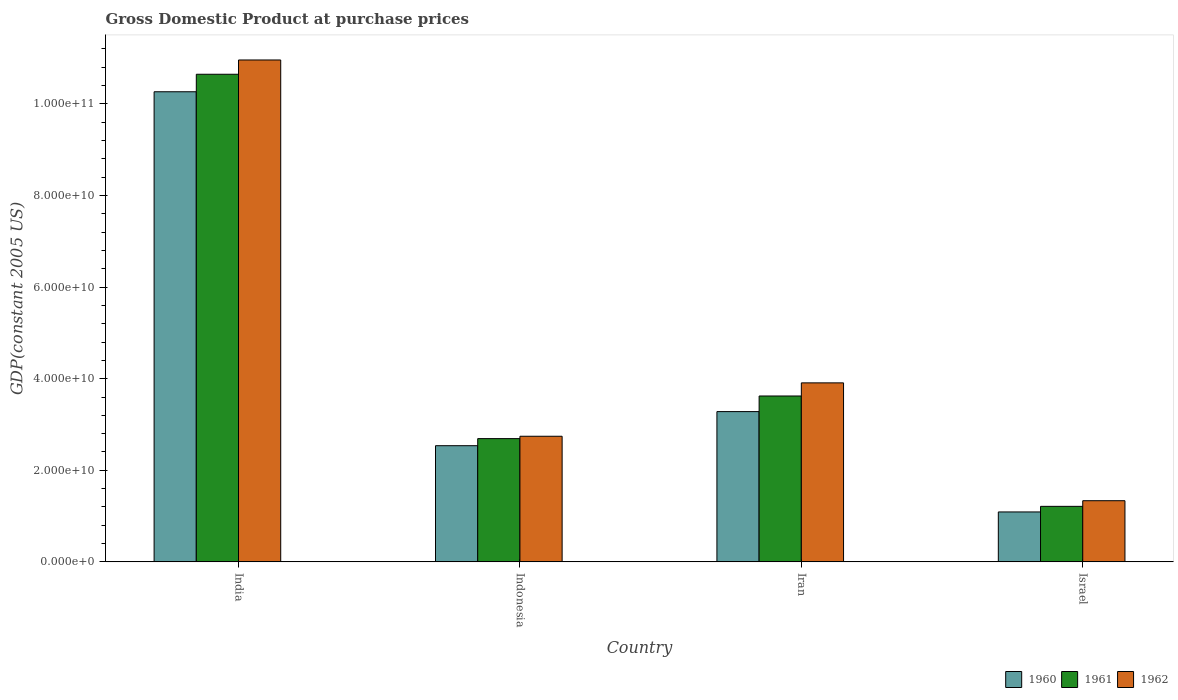Are the number of bars per tick equal to the number of legend labels?
Provide a short and direct response. Yes. Are the number of bars on each tick of the X-axis equal?
Offer a terse response. Yes. How many bars are there on the 1st tick from the left?
Your answer should be compact. 3. How many bars are there on the 1st tick from the right?
Ensure brevity in your answer.  3. What is the label of the 3rd group of bars from the left?
Keep it short and to the point. Iran. What is the GDP at purchase prices in 1960 in India?
Your answer should be very brief. 1.03e+11. Across all countries, what is the maximum GDP at purchase prices in 1961?
Keep it short and to the point. 1.06e+11. Across all countries, what is the minimum GDP at purchase prices in 1962?
Ensure brevity in your answer.  1.34e+1. In which country was the GDP at purchase prices in 1962 minimum?
Provide a succinct answer. Israel. What is the total GDP at purchase prices in 1961 in the graph?
Make the answer very short. 1.82e+11. What is the difference between the GDP at purchase prices in 1960 in Indonesia and that in Iran?
Provide a succinct answer. -7.45e+09. What is the difference between the GDP at purchase prices in 1960 in Israel and the GDP at purchase prices in 1961 in Indonesia?
Give a very brief answer. -1.60e+1. What is the average GDP at purchase prices in 1961 per country?
Keep it short and to the point. 4.54e+1. What is the difference between the GDP at purchase prices of/in 1961 and GDP at purchase prices of/in 1962 in Indonesia?
Offer a very short reply. -5.14e+08. What is the ratio of the GDP at purchase prices in 1960 in Iran to that in Israel?
Your answer should be very brief. 3.01. Is the GDP at purchase prices in 1961 in India less than that in Iran?
Your answer should be very brief. No. What is the difference between the highest and the second highest GDP at purchase prices in 1962?
Your answer should be very brief. 8.22e+1. What is the difference between the highest and the lowest GDP at purchase prices in 1962?
Your answer should be very brief. 9.62e+1. In how many countries, is the GDP at purchase prices in 1962 greater than the average GDP at purchase prices in 1962 taken over all countries?
Provide a succinct answer. 1. Is the sum of the GDP at purchase prices in 1960 in Indonesia and Israel greater than the maximum GDP at purchase prices in 1961 across all countries?
Your response must be concise. No. What does the 2nd bar from the left in India represents?
Offer a terse response. 1961. Is it the case that in every country, the sum of the GDP at purchase prices in 1960 and GDP at purchase prices in 1962 is greater than the GDP at purchase prices in 1961?
Your answer should be very brief. Yes. How many bars are there?
Your answer should be very brief. 12. Are all the bars in the graph horizontal?
Ensure brevity in your answer.  No. What is the difference between two consecutive major ticks on the Y-axis?
Give a very brief answer. 2.00e+1. Does the graph contain any zero values?
Keep it short and to the point. No. How are the legend labels stacked?
Your answer should be very brief. Horizontal. What is the title of the graph?
Your answer should be compact. Gross Domestic Product at purchase prices. What is the label or title of the X-axis?
Keep it short and to the point. Country. What is the label or title of the Y-axis?
Your response must be concise. GDP(constant 2005 US). What is the GDP(constant 2005 US) of 1960 in India?
Your response must be concise. 1.03e+11. What is the GDP(constant 2005 US) of 1961 in India?
Provide a succinct answer. 1.06e+11. What is the GDP(constant 2005 US) of 1962 in India?
Offer a very short reply. 1.10e+11. What is the GDP(constant 2005 US) of 1960 in Indonesia?
Keep it short and to the point. 2.54e+1. What is the GDP(constant 2005 US) in 1961 in Indonesia?
Ensure brevity in your answer.  2.69e+1. What is the GDP(constant 2005 US) in 1962 in Indonesia?
Provide a short and direct response. 2.74e+1. What is the GDP(constant 2005 US) of 1960 in Iran?
Make the answer very short. 3.28e+1. What is the GDP(constant 2005 US) in 1961 in Iran?
Give a very brief answer. 3.62e+1. What is the GDP(constant 2005 US) of 1962 in Iran?
Your answer should be very brief. 3.91e+1. What is the GDP(constant 2005 US) in 1960 in Israel?
Make the answer very short. 1.09e+1. What is the GDP(constant 2005 US) of 1961 in Israel?
Provide a succinct answer. 1.21e+1. What is the GDP(constant 2005 US) of 1962 in Israel?
Offer a very short reply. 1.34e+1. Across all countries, what is the maximum GDP(constant 2005 US) in 1960?
Your answer should be very brief. 1.03e+11. Across all countries, what is the maximum GDP(constant 2005 US) in 1961?
Provide a succinct answer. 1.06e+11. Across all countries, what is the maximum GDP(constant 2005 US) of 1962?
Your answer should be very brief. 1.10e+11. Across all countries, what is the minimum GDP(constant 2005 US) of 1960?
Offer a very short reply. 1.09e+1. Across all countries, what is the minimum GDP(constant 2005 US) of 1961?
Provide a short and direct response. 1.21e+1. Across all countries, what is the minimum GDP(constant 2005 US) in 1962?
Ensure brevity in your answer.  1.34e+1. What is the total GDP(constant 2005 US) of 1960 in the graph?
Your answer should be compact. 1.72e+11. What is the total GDP(constant 2005 US) in 1961 in the graph?
Give a very brief answer. 1.82e+11. What is the total GDP(constant 2005 US) of 1962 in the graph?
Offer a very short reply. 1.89e+11. What is the difference between the GDP(constant 2005 US) in 1960 in India and that in Indonesia?
Offer a terse response. 7.73e+1. What is the difference between the GDP(constant 2005 US) in 1961 in India and that in Indonesia?
Provide a short and direct response. 7.96e+1. What is the difference between the GDP(constant 2005 US) in 1962 in India and that in Indonesia?
Offer a very short reply. 8.22e+1. What is the difference between the GDP(constant 2005 US) of 1960 in India and that in Iran?
Provide a succinct answer. 6.98e+1. What is the difference between the GDP(constant 2005 US) of 1961 in India and that in Iran?
Offer a very short reply. 7.03e+1. What is the difference between the GDP(constant 2005 US) of 1962 in India and that in Iran?
Your answer should be very brief. 7.05e+1. What is the difference between the GDP(constant 2005 US) of 1960 in India and that in Israel?
Offer a very short reply. 9.18e+1. What is the difference between the GDP(constant 2005 US) of 1961 in India and that in Israel?
Your answer should be compact. 9.44e+1. What is the difference between the GDP(constant 2005 US) in 1962 in India and that in Israel?
Ensure brevity in your answer.  9.62e+1. What is the difference between the GDP(constant 2005 US) in 1960 in Indonesia and that in Iran?
Give a very brief answer. -7.45e+09. What is the difference between the GDP(constant 2005 US) in 1961 in Indonesia and that in Iran?
Offer a terse response. -9.31e+09. What is the difference between the GDP(constant 2005 US) of 1962 in Indonesia and that in Iran?
Ensure brevity in your answer.  -1.17e+1. What is the difference between the GDP(constant 2005 US) of 1960 in Indonesia and that in Israel?
Keep it short and to the point. 1.45e+1. What is the difference between the GDP(constant 2005 US) in 1961 in Indonesia and that in Israel?
Offer a terse response. 1.48e+1. What is the difference between the GDP(constant 2005 US) in 1962 in Indonesia and that in Israel?
Offer a terse response. 1.41e+1. What is the difference between the GDP(constant 2005 US) of 1960 in Iran and that in Israel?
Your answer should be compact. 2.19e+1. What is the difference between the GDP(constant 2005 US) in 1961 in Iran and that in Israel?
Your answer should be very brief. 2.41e+1. What is the difference between the GDP(constant 2005 US) in 1962 in Iran and that in Israel?
Your response must be concise. 2.57e+1. What is the difference between the GDP(constant 2005 US) of 1960 in India and the GDP(constant 2005 US) of 1961 in Indonesia?
Your response must be concise. 7.57e+1. What is the difference between the GDP(constant 2005 US) in 1960 in India and the GDP(constant 2005 US) in 1962 in Indonesia?
Your answer should be compact. 7.52e+1. What is the difference between the GDP(constant 2005 US) of 1961 in India and the GDP(constant 2005 US) of 1962 in Indonesia?
Ensure brevity in your answer.  7.90e+1. What is the difference between the GDP(constant 2005 US) in 1960 in India and the GDP(constant 2005 US) in 1961 in Iran?
Offer a terse response. 6.64e+1. What is the difference between the GDP(constant 2005 US) in 1960 in India and the GDP(constant 2005 US) in 1962 in Iran?
Your response must be concise. 6.36e+1. What is the difference between the GDP(constant 2005 US) in 1961 in India and the GDP(constant 2005 US) in 1962 in Iran?
Keep it short and to the point. 6.74e+1. What is the difference between the GDP(constant 2005 US) in 1960 in India and the GDP(constant 2005 US) in 1961 in Israel?
Provide a succinct answer. 9.05e+1. What is the difference between the GDP(constant 2005 US) of 1960 in India and the GDP(constant 2005 US) of 1962 in Israel?
Offer a terse response. 8.93e+1. What is the difference between the GDP(constant 2005 US) of 1961 in India and the GDP(constant 2005 US) of 1962 in Israel?
Ensure brevity in your answer.  9.31e+1. What is the difference between the GDP(constant 2005 US) of 1960 in Indonesia and the GDP(constant 2005 US) of 1961 in Iran?
Your answer should be very brief. -1.09e+1. What is the difference between the GDP(constant 2005 US) in 1960 in Indonesia and the GDP(constant 2005 US) in 1962 in Iran?
Provide a succinct answer. -1.37e+1. What is the difference between the GDP(constant 2005 US) in 1961 in Indonesia and the GDP(constant 2005 US) in 1962 in Iran?
Provide a succinct answer. -1.22e+1. What is the difference between the GDP(constant 2005 US) in 1960 in Indonesia and the GDP(constant 2005 US) in 1961 in Israel?
Your response must be concise. 1.32e+1. What is the difference between the GDP(constant 2005 US) in 1960 in Indonesia and the GDP(constant 2005 US) in 1962 in Israel?
Provide a succinct answer. 1.20e+1. What is the difference between the GDP(constant 2005 US) in 1961 in Indonesia and the GDP(constant 2005 US) in 1962 in Israel?
Ensure brevity in your answer.  1.36e+1. What is the difference between the GDP(constant 2005 US) in 1960 in Iran and the GDP(constant 2005 US) in 1961 in Israel?
Offer a terse response. 2.07e+1. What is the difference between the GDP(constant 2005 US) of 1960 in Iran and the GDP(constant 2005 US) of 1962 in Israel?
Provide a succinct answer. 1.95e+1. What is the difference between the GDP(constant 2005 US) in 1961 in Iran and the GDP(constant 2005 US) in 1962 in Israel?
Your answer should be compact. 2.29e+1. What is the average GDP(constant 2005 US) of 1960 per country?
Your answer should be very brief. 4.29e+1. What is the average GDP(constant 2005 US) of 1961 per country?
Your answer should be very brief. 4.54e+1. What is the average GDP(constant 2005 US) of 1962 per country?
Provide a succinct answer. 4.74e+1. What is the difference between the GDP(constant 2005 US) of 1960 and GDP(constant 2005 US) of 1961 in India?
Your response must be concise. -3.82e+09. What is the difference between the GDP(constant 2005 US) of 1960 and GDP(constant 2005 US) of 1962 in India?
Provide a succinct answer. -6.94e+09. What is the difference between the GDP(constant 2005 US) of 1961 and GDP(constant 2005 US) of 1962 in India?
Provide a short and direct response. -3.12e+09. What is the difference between the GDP(constant 2005 US) of 1960 and GDP(constant 2005 US) of 1961 in Indonesia?
Provide a succinct answer. -1.55e+09. What is the difference between the GDP(constant 2005 US) of 1960 and GDP(constant 2005 US) of 1962 in Indonesia?
Make the answer very short. -2.06e+09. What is the difference between the GDP(constant 2005 US) in 1961 and GDP(constant 2005 US) in 1962 in Indonesia?
Your answer should be compact. -5.14e+08. What is the difference between the GDP(constant 2005 US) in 1960 and GDP(constant 2005 US) in 1961 in Iran?
Offer a very short reply. -3.41e+09. What is the difference between the GDP(constant 2005 US) of 1960 and GDP(constant 2005 US) of 1962 in Iran?
Your answer should be very brief. -6.27e+09. What is the difference between the GDP(constant 2005 US) of 1961 and GDP(constant 2005 US) of 1962 in Iran?
Your response must be concise. -2.87e+09. What is the difference between the GDP(constant 2005 US) of 1960 and GDP(constant 2005 US) of 1961 in Israel?
Your answer should be compact. -1.22e+09. What is the difference between the GDP(constant 2005 US) of 1960 and GDP(constant 2005 US) of 1962 in Israel?
Offer a terse response. -2.45e+09. What is the difference between the GDP(constant 2005 US) of 1961 and GDP(constant 2005 US) of 1962 in Israel?
Ensure brevity in your answer.  -1.23e+09. What is the ratio of the GDP(constant 2005 US) of 1960 in India to that in Indonesia?
Provide a succinct answer. 4.05. What is the ratio of the GDP(constant 2005 US) of 1961 in India to that in Indonesia?
Provide a succinct answer. 3.96. What is the ratio of the GDP(constant 2005 US) of 1962 in India to that in Indonesia?
Provide a succinct answer. 4. What is the ratio of the GDP(constant 2005 US) in 1960 in India to that in Iran?
Your response must be concise. 3.13. What is the ratio of the GDP(constant 2005 US) of 1961 in India to that in Iran?
Give a very brief answer. 2.94. What is the ratio of the GDP(constant 2005 US) in 1962 in India to that in Iran?
Provide a succinct answer. 2.8. What is the ratio of the GDP(constant 2005 US) of 1960 in India to that in Israel?
Provide a short and direct response. 9.41. What is the ratio of the GDP(constant 2005 US) in 1961 in India to that in Israel?
Offer a very short reply. 8.78. What is the ratio of the GDP(constant 2005 US) in 1962 in India to that in Israel?
Ensure brevity in your answer.  8.21. What is the ratio of the GDP(constant 2005 US) in 1960 in Indonesia to that in Iran?
Make the answer very short. 0.77. What is the ratio of the GDP(constant 2005 US) of 1961 in Indonesia to that in Iran?
Make the answer very short. 0.74. What is the ratio of the GDP(constant 2005 US) of 1962 in Indonesia to that in Iran?
Your answer should be very brief. 0.7. What is the ratio of the GDP(constant 2005 US) of 1960 in Indonesia to that in Israel?
Offer a terse response. 2.33. What is the ratio of the GDP(constant 2005 US) of 1961 in Indonesia to that in Israel?
Your answer should be very brief. 2.22. What is the ratio of the GDP(constant 2005 US) in 1962 in Indonesia to that in Israel?
Give a very brief answer. 2.05. What is the ratio of the GDP(constant 2005 US) in 1960 in Iran to that in Israel?
Your answer should be very brief. 3.01. What is the ratio of the GDP(constant 2005 US) of 1961 in Iran to that in Israel?
Your response must be concise. 2.99. What is the ratio of the GDP(constant 2005 US) of 1962 in Iran to that in Israel?
Give a very brief answer. 2.93. What is the difference between the highest and the second highest GDP(constant 2005 US) in 1960?
Your answer should be very brief. 6.98e+1. What is the difference between the highest and the second highest GDP(constant 2005 US) in 1961?
Make the answer very short. 7.03e+1. What is the difference between the highest and the second highest GDP(constant 2005 US) of 1962?
Give a very brief answer. 7.05e+1. What is the difference between the highest and the lowest GDP(constant 2005 US) of 1960?
Keep it short and to the point. 9.18e+1. What is the difference between the highest and the lowest GDP(constant 2005 US) in 1961?
Give a very brief answer. 9.44e+1. What is the difference between the highest and the lowest GDP(constant 2005 US) of 1962?
Offer a very short reply. 9.62e+1. 